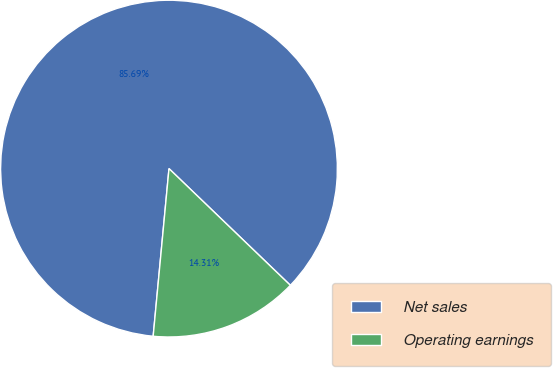Convert chart. <chart><loc_0><loc_0><loc_500><loc_500><pie_chart><fcel>Net sales<fcel>Operating earnings<nl><fcel>85.69%<fcel>14.31%<nl></chart> 